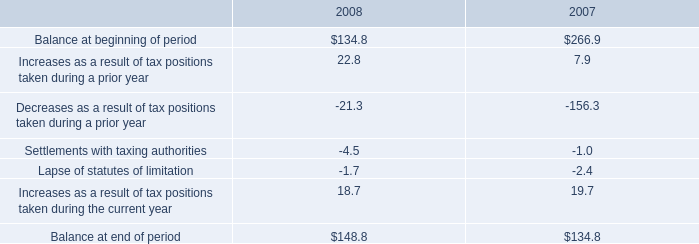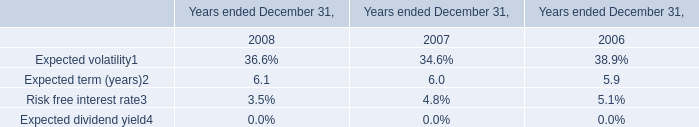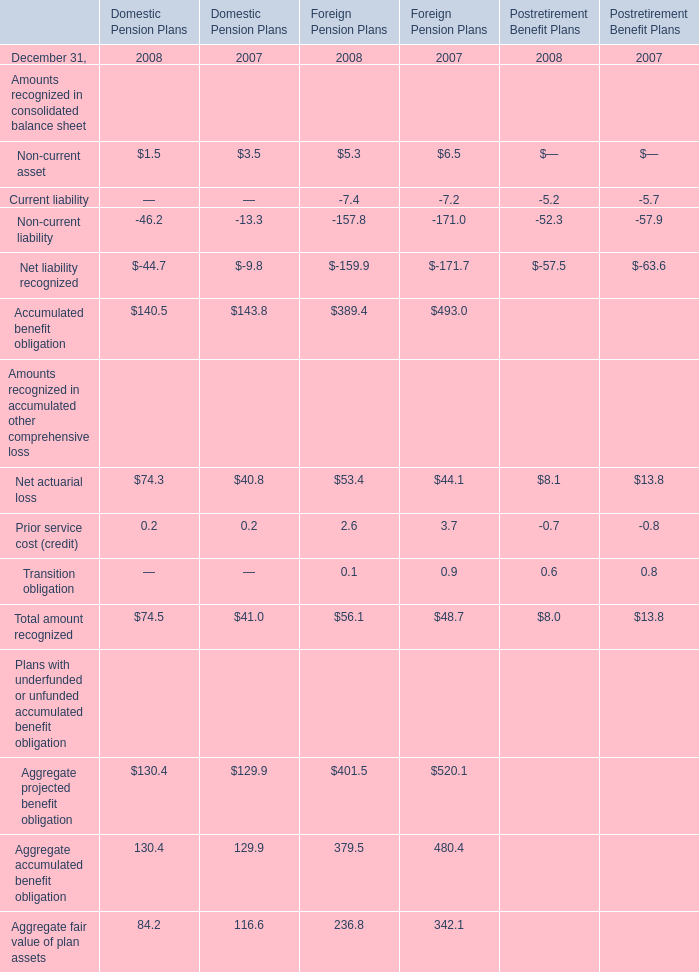what percentage of unrecognized tax benefits , in 2008 , is from tax benefits that would impact effective tax rate if recognized? 
Computations: ((131.8 / 148.8) * 100)
Answer: 88.57527. 